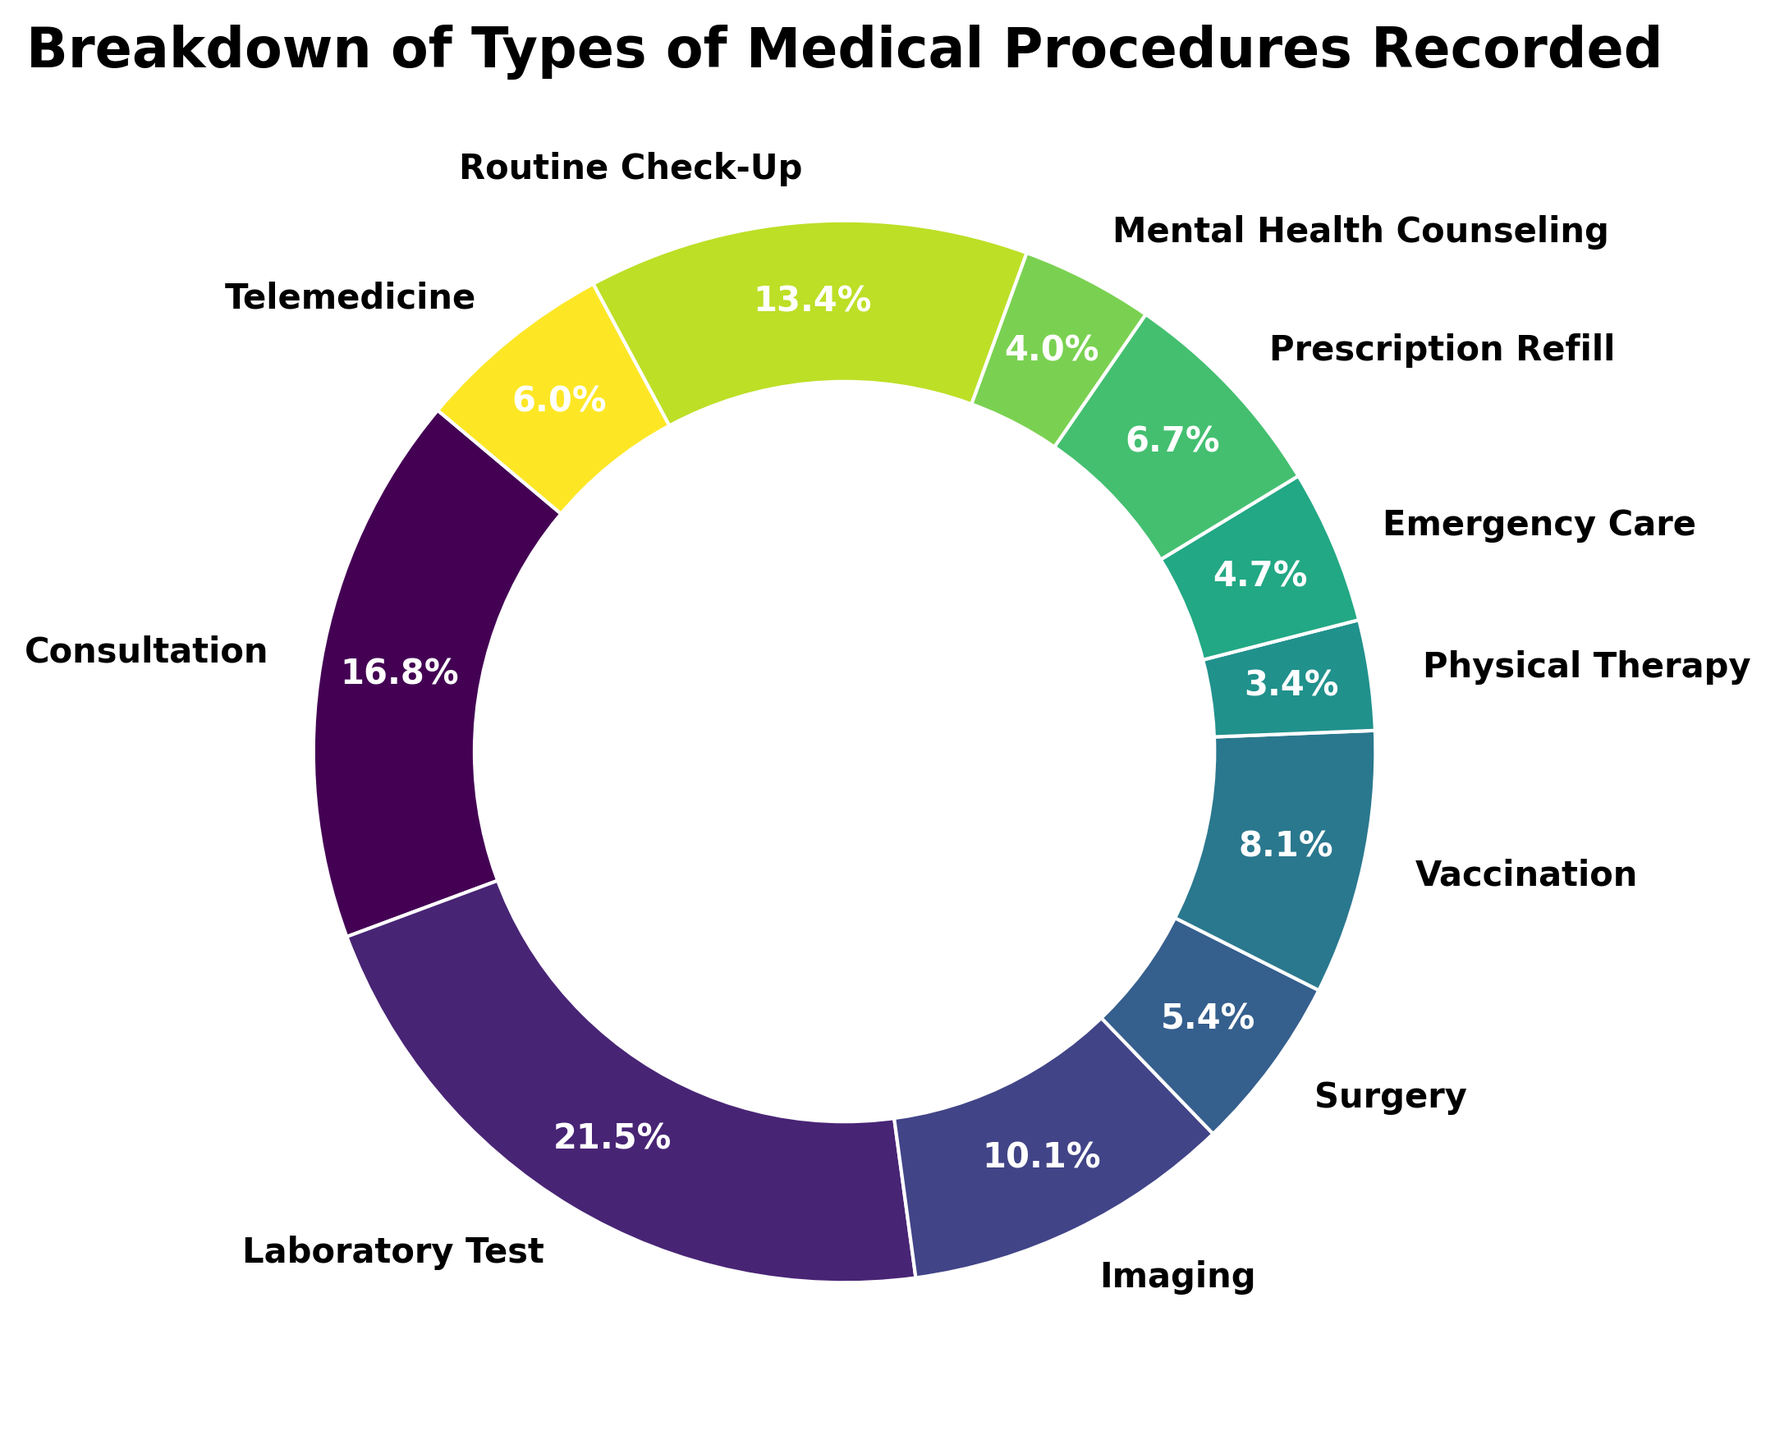What percentage of the total procedures is made up by Consultation and Surgery combined? First, locate the percentages for Consultation and Surgery. According to the pie chart, Consultation is 19.4% and Surgery is 6.2%. Add these two percentages together: 19.4% + 6.2% = 25.6%.
Answer: 25.6% Which category has the highest percentage of recorded procedures? Identify the largest wedge in the pie chart by observing its size and the associated percentage labels. Laboratory Test holds the largest portion at 24.8%.
Answer: Laboratory Test Are Vaccination and Emergency Care combined larger than Imaging? First, locate their individual percentages from the chart: Vaccination is 9.3% and Emergency Care is 5.4%. Adding these together, 9.3% + 5.4% = 14.7%. Imaging is 11.6%. Comparing the two sums, 14.7% (Vaccination and Emergency Care) is greater than 11.6% (Imaging).
Answer: Yes Which type of medical procedure has the smallest recorded percentage, and what is it? Identify the smallest wedge in the pie chart by looking at the labels and their associated percentages. Physical Therapy is the smallest with 3.9%.
Answer: Physical Therapy, 3.9% What is the combined percentage of Telemedicine and Mental Health Counseling? First, locate the percentages from the chart: Telemedicine is 7.0% and Mental Health Counseling is 4.6%. Add them together: 7.0% + 4.6% = 11.6%.
Answer: 11.6% How does the percentage of Prescription Refill compare to Routine Check-Up? Refer to the chart to find their percentages: Prescription Refill is 7.8% and Routine Check-Up is 15.5%. Since 7.8% is less than 15.5%, Prescription Refill is smaller.
Answer: Prescription Refill is less than Routine Check-Up What is the difference in percentage between the most and least common procedures recorded? The most common procedure is Laboratory Test at 24.8%, and the least common is Physical Therapy at 3.9%. Subtract the smaller percentage from the larger: 24.8% - 3.9% = 20.9%.
Answer: 20.9% Are there more Consultations or Routine Check-Ups in percentage terms? Compare the percentages of Consultations and Routine Check-Ups. Consultation is at 19.4% and Routine Check-Up is at 15.5%. Since 19.4% is greater than 15.5%, there are more Consultations.
Answer: Consultations Which three categories combined make up approximately half of the total recorded procedures? To find this, identify the categories with large percentages and add them. Laboratory Test is 24.8%, Consultation is 19.4%, and Routine Check-Up is 15.5%. Adding these: 24.8% + 19.4% + 15.5% = 59.7%, which is more than half.
Answer: Laboratory Test, Consultation, Routine Check-Up 